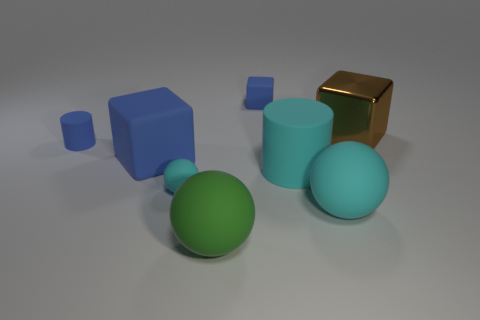There is a brown metal object that is the same shape as the big blue thing; what is its size?
Provide a succinct answer. Large. How many big blue objects have the same material as the large brown object?
Your answer should be very brief. 0. There is a small matte block; is its color the same as the cylinder that is in front of the blue matte cylinder?
Your answer should be compact. No. Are there more brown metallic blocks than small blue metallic cubes?
Keep it short and to the point. Yes. What is the color of the tiny cylinder?
Your answer should be compact. Blue. Does the rubber cube behind the large brown metallic block have the same color as the large matte block?
Ensure brevity in your answer.  Yes. There is a large cube that is the same color as the tiny rubber cube; what is its material?
Provide a short and direct response. Rubber. What number of other rubber balls are the same color as the small ball?
Ensure brevity in your answer.  1. There is a small blue rubber object on the right side of the large green matte thing; does it have the same shape as the tiny cyan object?
Offer a very short reply. No. Is the number of cubes to the left of the cyan cylinder less than the number of big brown cubes on the right side of the brown thing?
Your response must be concise. No. 